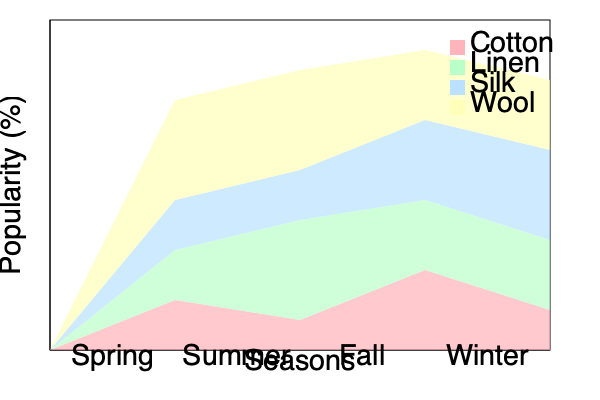Based on the stacked area chart showing the popularity of different textile materials across seasons, which material experiences the most significant increase in popularity from Summer to Fall? To determine which material has the most significant increase in popularity from Summer to Fall, we need to analyze the change in area for each material between these two seasons. Let's break it down step-by-step:

1. Identify the materials: Cotton (pink), Linen (green), Silk (blue), and Wool (yellow).

2. Compare Summer (second column) to Fall (third column) for each material:

   a) Cotton: The area slightly decreases from Summer to Fall.
   b) Linen: The area remains relatively stable with a slight decrease.
   c) Silk: The area increases noticeably from Summer to Fall.
   d) Wool: The area increases significantly from Summer to Fall.

3. Quantify the changes:
   While we don't have exact numbers, we can visually estimate the relative changes:
   
   Cotton: Small decrease (≈ -5%)
   Linen: Slight decrease (≈ -2%)
   Silk: Moderate increase (≈ +15%)
   Wool: Large increase (≈ +30%)

4. Identify the material with the most significant increase:
   Wool shows the largest positive change in area from Summer to Fall.

Therefore, based on the visual representation, wool experiences the most significant increase in popularity from Summer to Fall.
Answer: Wool 